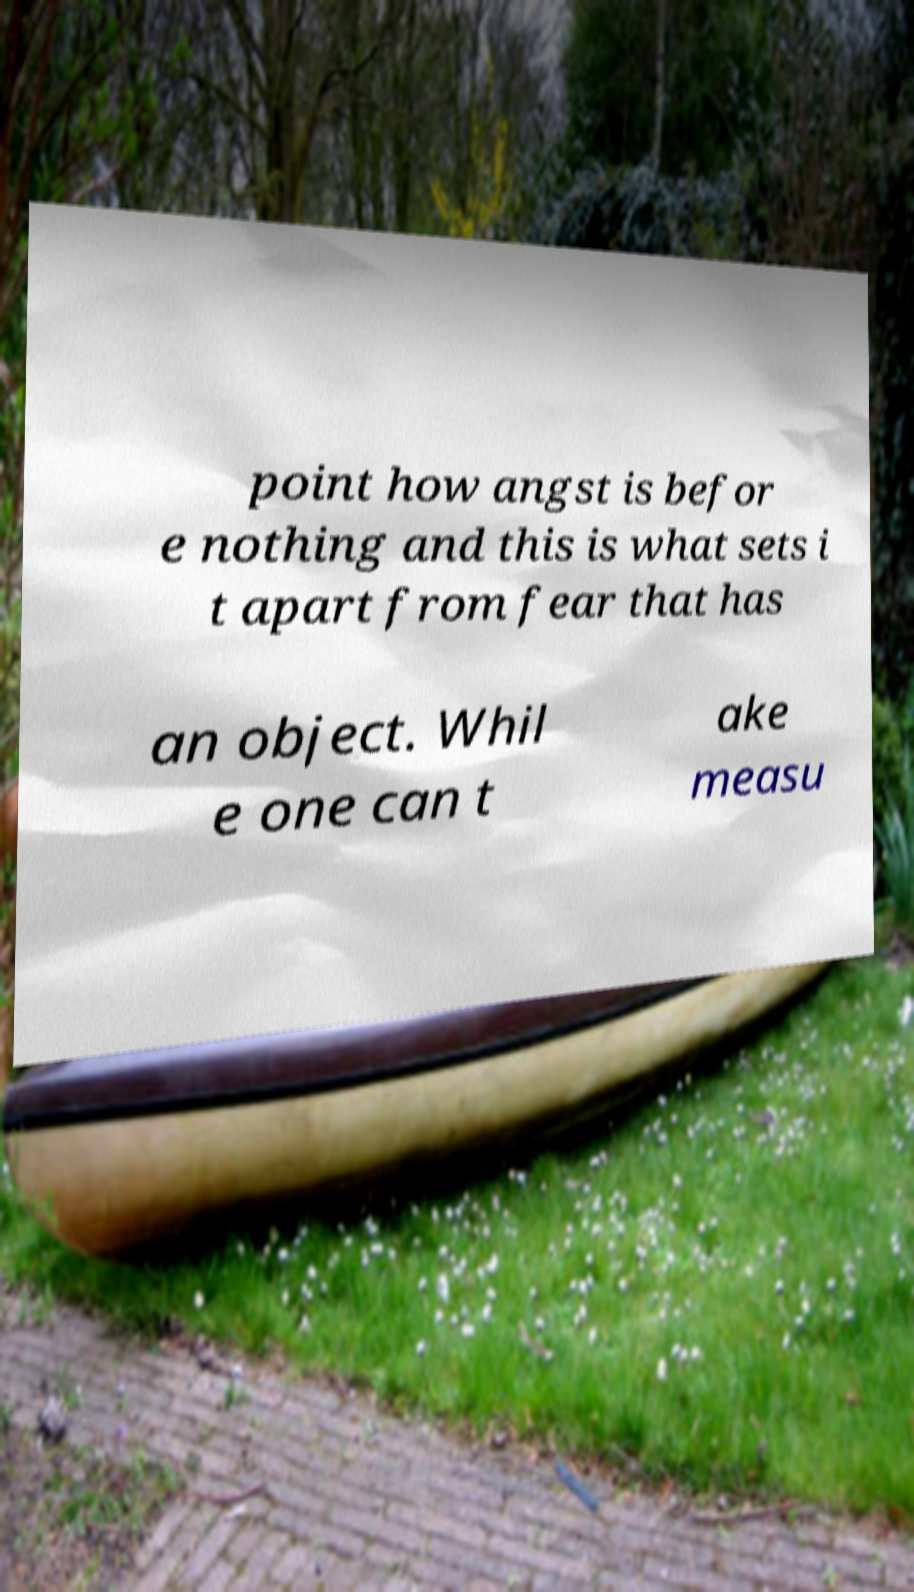For documentation purposes, I need the text within this image transcribed. Could you provide that? point how angst is befor e nothing and this is what sets i t apart from fear that has an object. Whil e one can t ake measu 